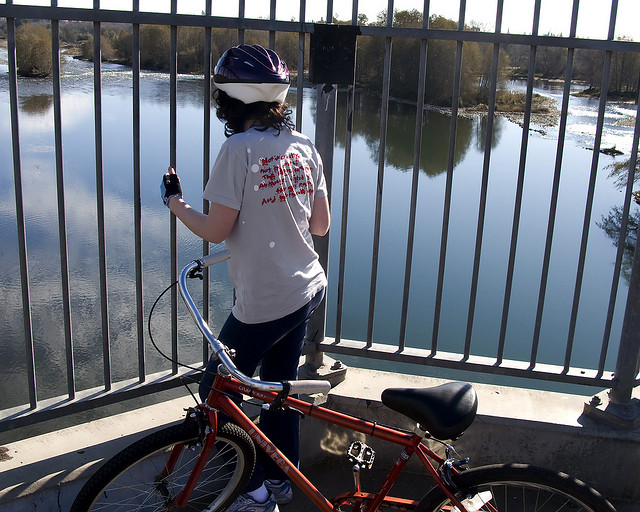Please identify all text content in this image. INIVEGA 